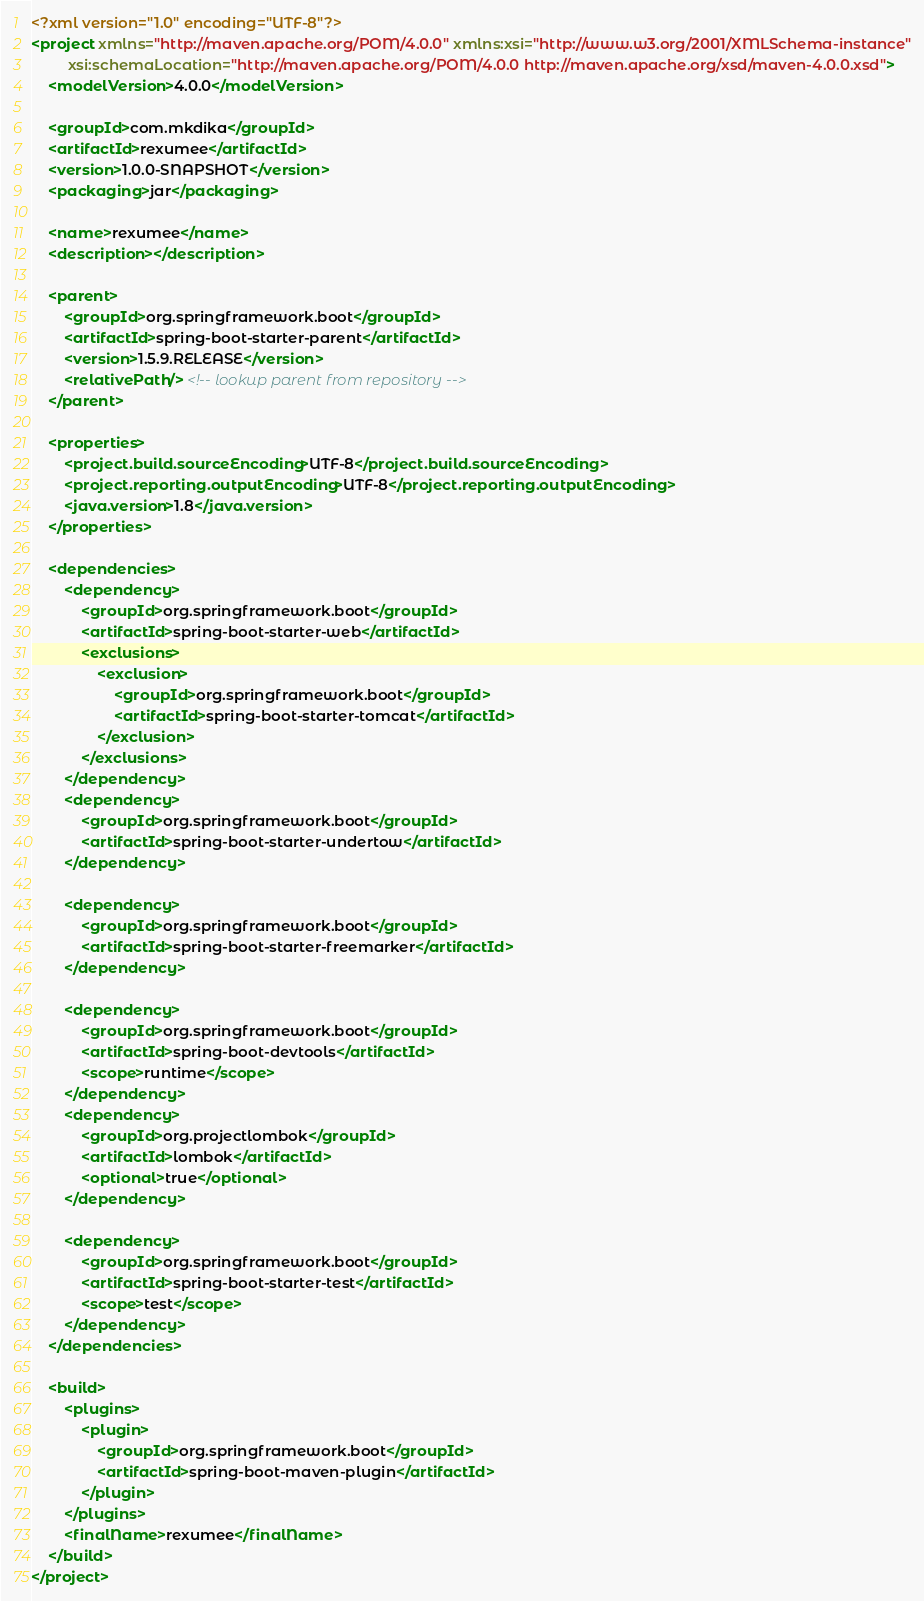<code> <loc_0><loc_0><loc_500><loc_500><_XML_><?xml version="1.0" encoding="UTF-8"?>
<project xmlns="http://maven.apache.org/POM/4.0.0" xmlns:xsi="http://www.w3.org/2001/XMLSchema-instance"
         xsi:schemaLocation="http://maven.apache.org/POM/4.0.0 http://maven.apache.org/xsd/maven-4.0.0.xsd">
    <modelVersion>4.0.0</modelVersion>

    <groupId>com.mkdika</groupId>
    <artifactId>rexumee</artifactId>
    <version>1.0.0-SNAPSHOT</version>
    <packaging>jar</packaging>

    <name>rexumee</name>
    <description></description>

    <parent>
        <groupId>org.springframework.boot</groupId>
        <artifactId>spring-boot-starter-parent</artifactId>
        <version>1.5.9.RELEASE</version>
        <relativePath/> <!-- lookup parent from repository -->
    </parent>

    <properties>
        <project.build.sourceEncoding>UTF-8</project.build.sourceEncoding>
        <project.reporting.outputEncoding>UTF-8</project.reporting.outputEncoding>
        <java.version>1.8</java.version>
    </properties>

    <dependencies>
        <dependency>
            <groupId>org.springframework.boot</groupId>
            <artifactId>spring-boot-starter-web</artifactId>
            <exclusions>
                <exclusion>
                    <groupId>org.springframework.boot</groupId>
                    <artifactId>spring-boot-starter-tomcat</artifactId>
                </exclusion>
            </exclusions>
        </dependency>
        <dependency>
            <groupId>org.springframework.boot</groupId>
            <artifactId>spring-boot-starter-undertow</artifactId>
        </dependency>
        
        <dependency>
            <groupId>org.springframework.boot</groupId>
            <artifactId>spring-boot-starter-freemarker</artifactId>
        </dependency>

        <dependency>
            <groupId>org.springframework.boot</groupId>
            <artifactId>spring-boot-devtools</artifactId>
            <scope>runtime</scope>
        </dependency>
        <dependency>
            <groupId>org.projectlombok</groupId>
            <artifactId>lombok</artifactId>
            <optional>true</optional>
        </dependency>
              
        <dependency>
            <groupId>org.springframework.boot</groupId>
            <artifactId>spring-boot-starter-test</artifactId>
            <scope>test</scope>
        </dependency>
    </dependencies>

    <build>
        <plugins>
            <plugin>
                <groupId>org.springframework.boot</groupId>
                <artifactId>spring-boot-maven-plugin</artifactId>
            </plugin>
        </plugins>
        <finalName>rexumee</finalName>
    </build>
</project>
</code> 